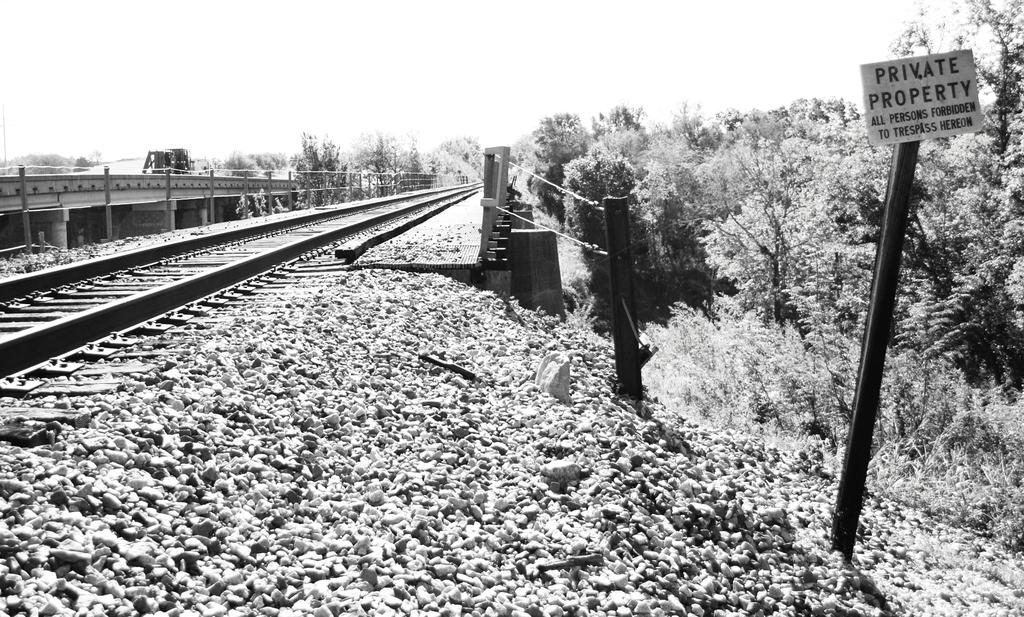What can be seen on the left side of the image? There is a railway track on the left side of the image. What structure is present in the image? There is a bridge in the image. What type of vegetation is visible in the background of the image? There are trees in the background of the image. What part of the natural environment is visible in the image? The sky is visible in the background of the image. What is located on the right side of the image? There is a board and stones visible on the right side of the image. What color is the blood pumping through the bridge in the image? There is no blood or pump present in the image; it features a railway track, a bridge, trees, and stones. How does the bridge change its appearance throughout the day in the image? The image is static, so the bridge's appearance does not change throughout the day. 